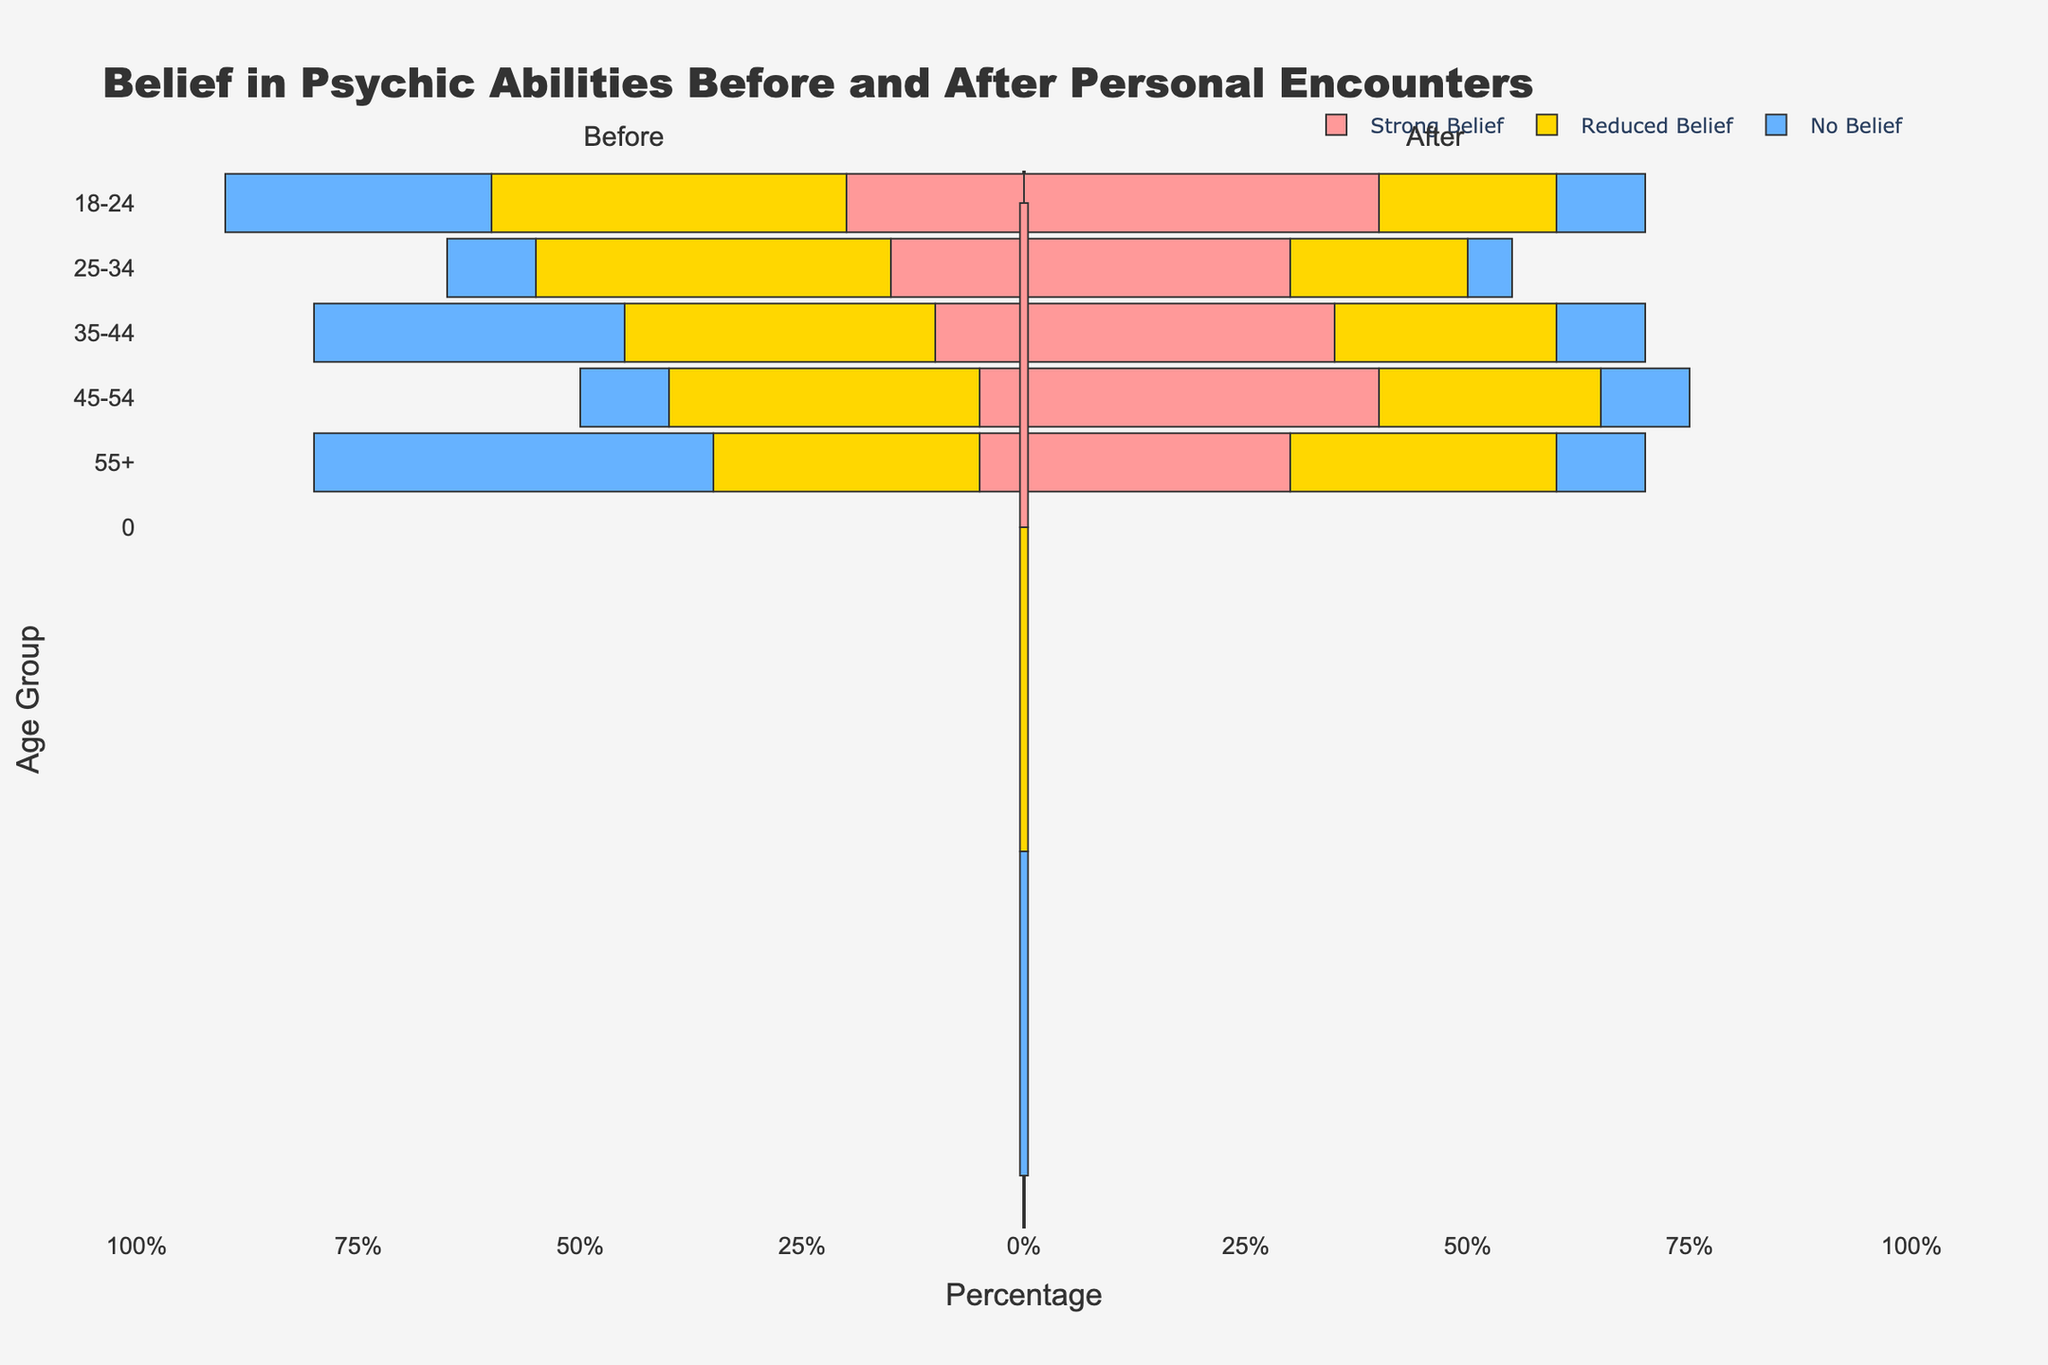What percentage of the 35-44 age group retained a strong belief in psychic abilities after a personal encounter? For the 35-44 age group, the bar representing "Strong Belief" (Before) shows 30% and after 10%, retaining the percentage is from the group having had a strong belief before.
Answer: 10% Which age group experienced the highest reduction in belief in psychic abilities after a personal encounter? To determine the highest reduction, check where the change from "Strong Belief" (Before) to "No Belief" (After) is most significant. For the 45-54 age group, "Strong Belief" falls from 25% to 5%, indicating a 20% change, which is the highest compared to other age groups.
Answer: 45-54 What is the sum of percentages for the 18-24 age group that retained or reduced their belief after personal encounters? For 18-24, add the percentages that retained "Strong Belief" (20%) and those who moved to "Reduced Belief" (40%). Thus, 20% + 40% = 60%.
Answer: 60% Which belief before a personal encounter is most common in the 55+ age group? Identify the highest bar segment for "Belief Before Encounter" in the 55+ group. "Strong Belief" has the highest value before the encounter at 40%.
Answer: Strong Belief Compare the percentage of the 25-34 age group that moved from a "Strong Belief" to a "No Belief" before and after personal encounters. In the 25-34 age group, the transition from "Strong Belief" directly to "No Belief" is not explicitly shown; calculate by combining segments. Before, 35% had a strong belief and after only 15% retained. Evaluate the drop adjusted by remaining segments.
Answer: Reduced Belief & No Belief increase 60% What is the overall trend in belief in psychic abilities after personal encounters across all age groups? Summarize data: Calculate percentage shifts from "Strong Belief" to reduced or no belief for each age group. Most groups show decreased overall strong belief and increased reduced or no beliefs, showing a general decline.
Answer: Decreasing What is the decrease in percentage of strong belief in the 45-54 age group after personal encounters? From the data, for the 45-54 group, "Strong Belief" goes from 25% before to 5% after the encounter, a decrease of 20%.
Answer: 20% Which age group had the highest percentage of individuals with no belief in psychic abilities before and after personal encounters? Check for "No Belief" both before and after. Each age group shows 10% for No Belief post-encounter. Thus, equal across groups.
Answer: Equal across all age groups 